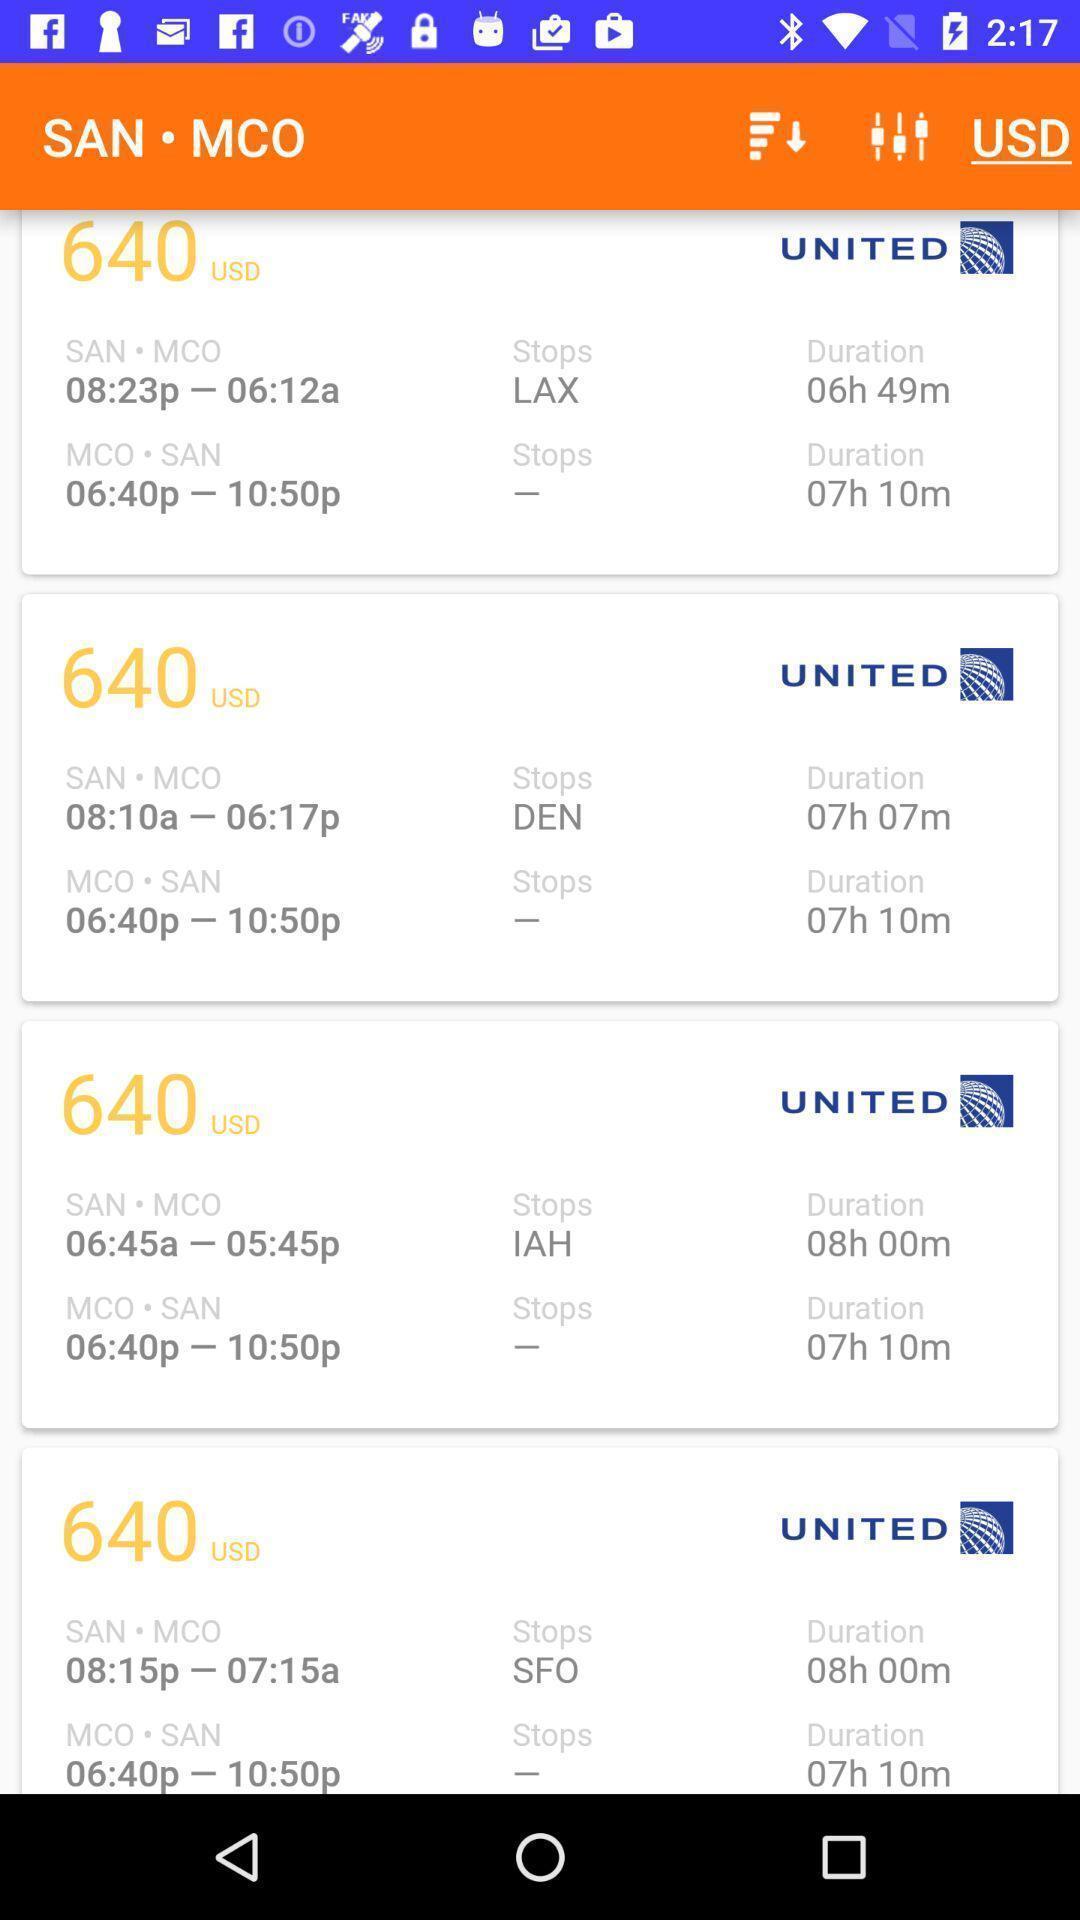Explain the elements present in this screenshot. Page displaying list of flights details. 